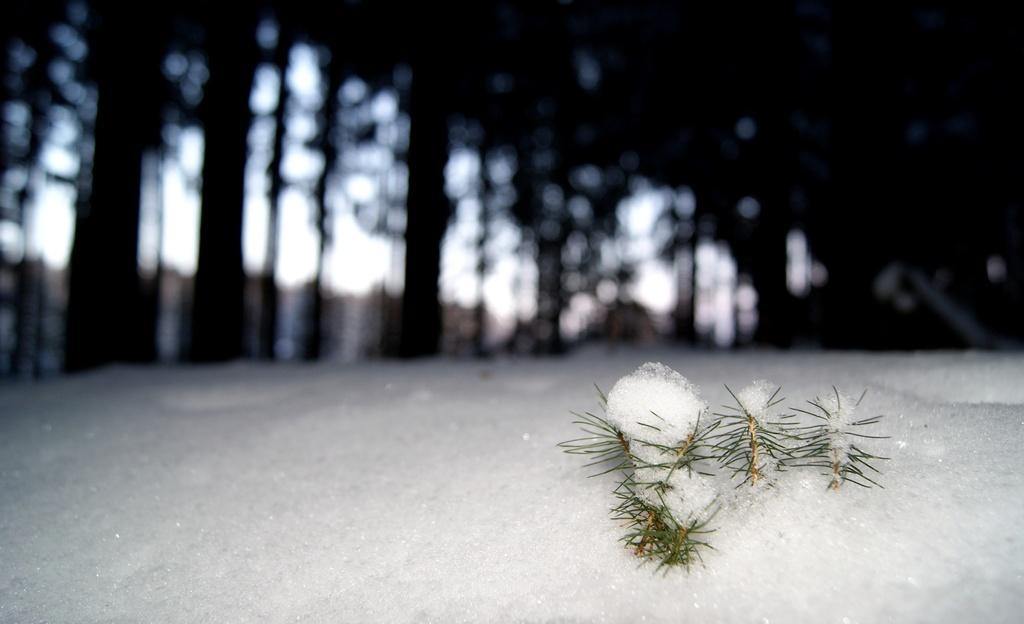What type of natural environment is depicted in the front of the image? There is snow and grass in the front of the image. Can you describe the background of the image? The background of the image is blurry. What type of vegetation can be seen in the background of the image? Trees are visible in the background of the image. What type of jelly is being offered to the trees in the image? There is no jelly or any offering present in the image; it features snow, grass, and trees. 